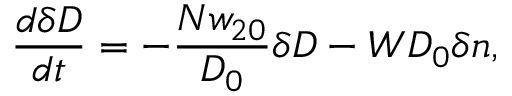<formula> <loc_0><loc_0><loc_500><loc_500>\frac { d \delta D } { d t } = - \frac { N w _ { 2 0 } } { D _ { 0 } } \delta D - W D _ { 0 } \delta n ,</formula> 